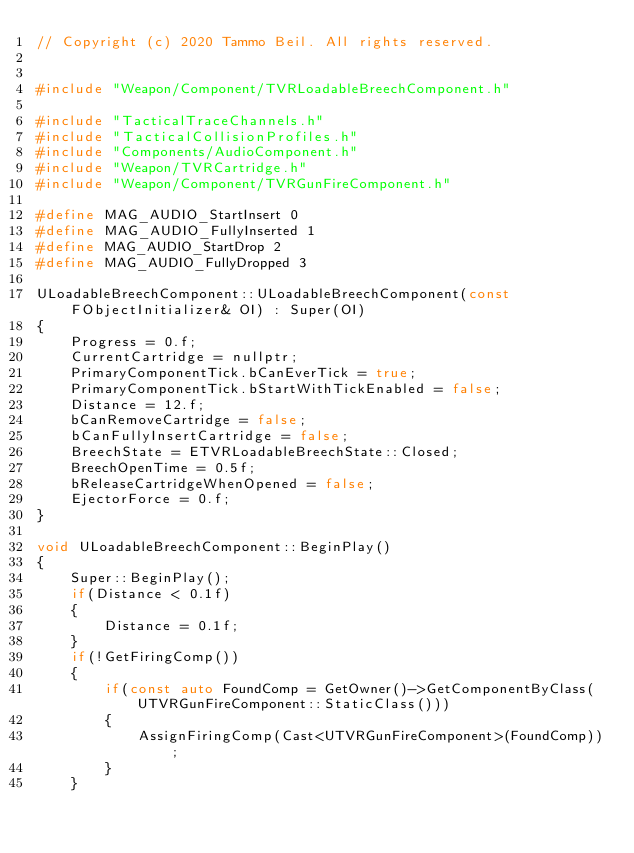Convert code to text. <code><loc_0><loc_0><loc_500><loc_500><_C++_>// Copyright (c) 2020 Tammo Beil. All rights reserved.


#include "Weapon/Component/TVRLoadableBreechComponent.h"

#include "TacticalTraceChannels.h"
#include "TacticalCollisionProfiles.h"
#include "Components/AudioComponent.h"
#include "Weapon/TVRCartridge.h"
#include "Weapon/Component/TVRGunFireComponent.h"

#define MAG_AUDIO_StartInsert 0
#define MAG_AUDIO_FullyInserted 1
#define MAG_AUDIO_StartDrop 2
#define MAG_AUDIO_FullyDropped 3

ULoadableBreechComponent::ULoadableBreechComponent(const FObjectInitializer& OI) : Super(OI)
{
	Progress = 0.f;
	CurrentCartridge = nullptr;
	PrimaryComponentTick.bCanEverTick = true;
	PrimaryComponentTick.bStartWithTickEnabled = false;
	Distance = 12.f;
	bCanRemoveCartridge = false;
	bCanFullyInsertCartridge = false;
	BreechState = ETVRLoadableBreechState::Closed;
	BreechOpenTime = 0.5f;
	bReleaseCartridgeWhenOpened = false;
	EjectorForce = 0.f;
}

void ULoadableBreechComponent::BeginPlay()
{
	Super::BeginPlay();
	if(Distance < 0.1f)
	{
		Distance = 0.1f;
	}
	if(!GetFiringComp())
	{
		if(const auto FoundComp = GetOwner()->GetComponentByClass(UTVRGunFireComponent::StaticClass()))
		{
			AssignFiringComp(Cast<UTVRGunFireComponent>(FoundComp));
		}
	}
</code> 